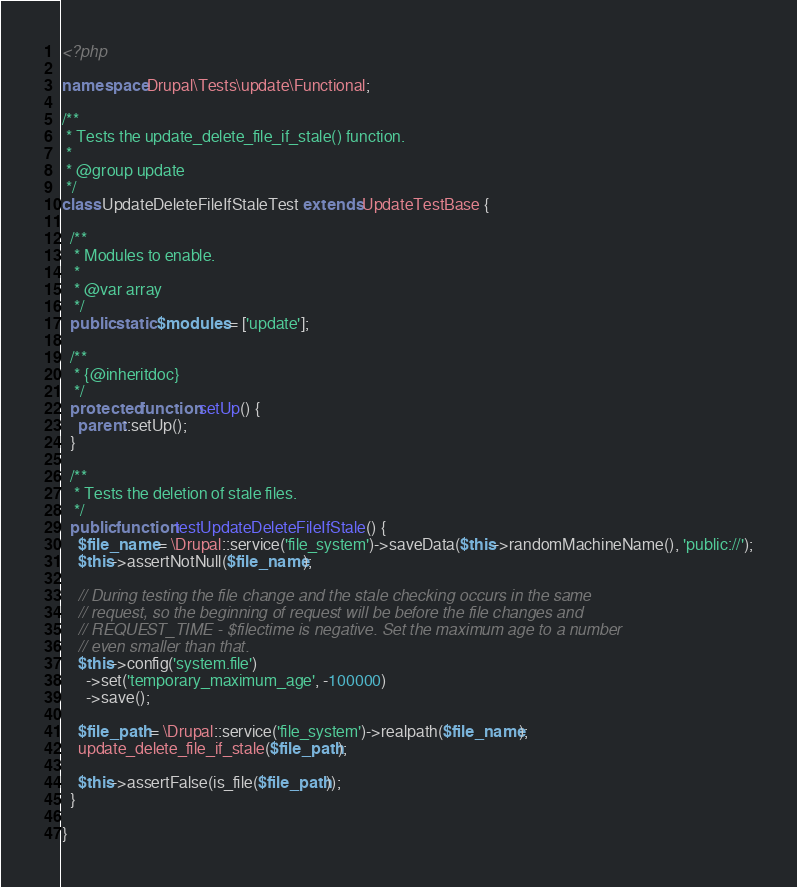<code> <loc_0><loc_0><loc_500><loc_500><_PHP_><?php

namespace Drupal\Tests\update\Functional;

/**
 * Tests the update_delete_file_if_stale() function.
 *
 * @group update
 */
class UpdateDeleteFileIfStaleTest extends UpdateTestBase {

  /**
   * Modules to enable.
   *
   * @var array
   */
  public static $modules = ['update'];

  /**
   * {@inheritdoc}
   */
  protected function setUp() {
    parent::setUp();
  }

  /**
   * Tests the deletion of stale files.
   */
  public function testUpdateDeleteFileIfStale() {
    $file_name = \Drupal::service('file_system')->saveData($this->randomMachineName(), 'public://');
    $this->assertNotNull($file_name);

    // During testing the file change and the stale checking occurs in the same
    // request, so the beginning of request will be before the file changes and
    // REQUEST_TIME - $filectime is negative. Set the maximum age to a number
    // even smaller than that.
    $this->config('system.file')
      ->set('temporary_maximum_age', -100000)
      ->save();

    $file_path = \Drupal::service('file_system')->realpath($file_name);
    update_delete_file_if_stale($file_path);

    $this->assertFalse(is_file($file_path));
  }

}
</code> 